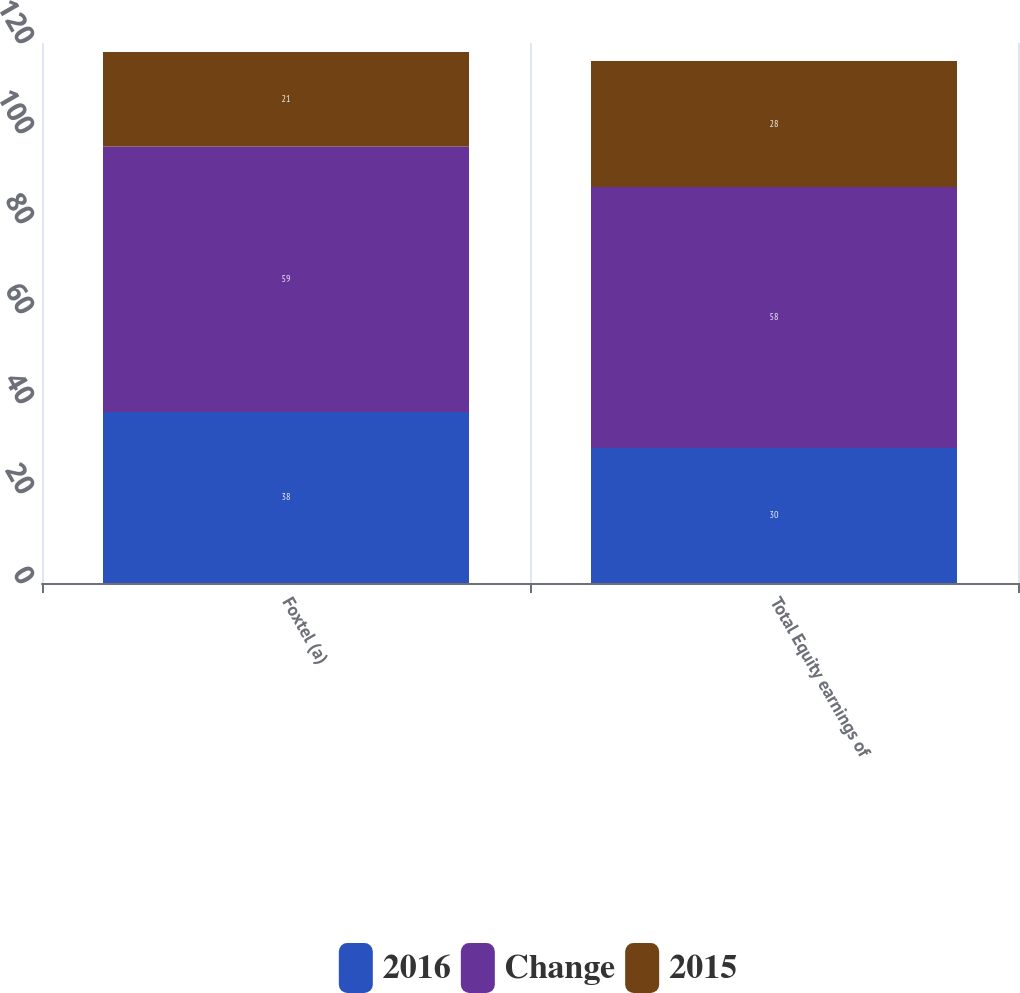Convert chart. <chart><loc_0><loc_0><loc_500><loc_500><stacked_bar_chart><ecel><fcel>Foxtel (a)<fcel>Total Equity earnings of<nl><fcel>2016<fcel>38<fcel>30<nl><fcel>Change<fcel>59<fcel>58<nl><fcel>2015<fcel>21<fcel>28<nl></chart> 